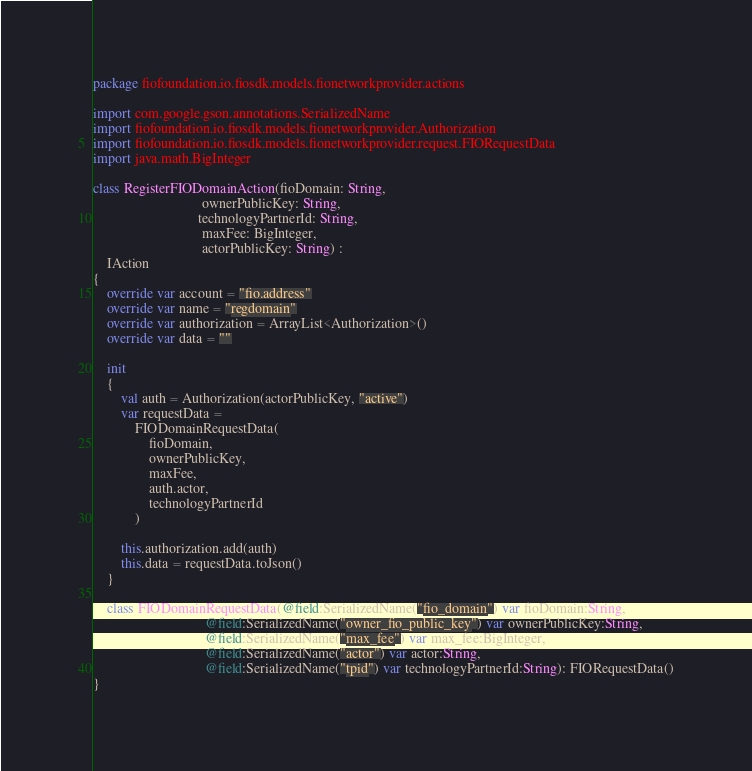<code> <loc_0><loc_0><loc_500><loc_500><_Kotlin_>package fiofoundation.io.fiosdk.models.fionetworkprovider.actions

import com.google.gson.annotations.SerializedName
import fiofoundation.io.fiosdk.models.fionetworkprovider.Authorization
import fiofoundation.io.fiosdk.models.fionetworkprovider.request.FIORequestData
import java.math.BigInteger

class RegisterFIODomainAction(fioDomain: String,
                               ownerPublicKey: String,
                              technologyPartnerId: String,
                               maxFee: BigInteger,
                               actorPublicKey: String) :
    IAction
{
    override var account = "fio.address"
    override var name = "regdomain"
    override var authorization = ArrayList<Authorization>()
    override var data = ""

    init
    {
        val auth = Authorization(actorPublicKey, "active")
        var requestData =
            FIODomainRequestData(
                fioDomain,
                ownerPublicKey,
                maxFee,
                auth.actor,
                technologyPartnerId
            )

        this.authorization.add(auth)
        this.data = requestData.toJson()
    }

    class FIODomainRequestData(@field:SerializedName("fio_domain") var fioDomain:String,
                                @field:SerializedName("owner_fio_public_key") var ownerPublicKey:String,
                                @field:SerializedName("max_fee") var max_fee:BigInteger,
                                @field:SerializedName("actor") var actor:String,
                                @field:SerializedName("tpid") var technologyPartnerId:String): FIORequestData()
}</code> 